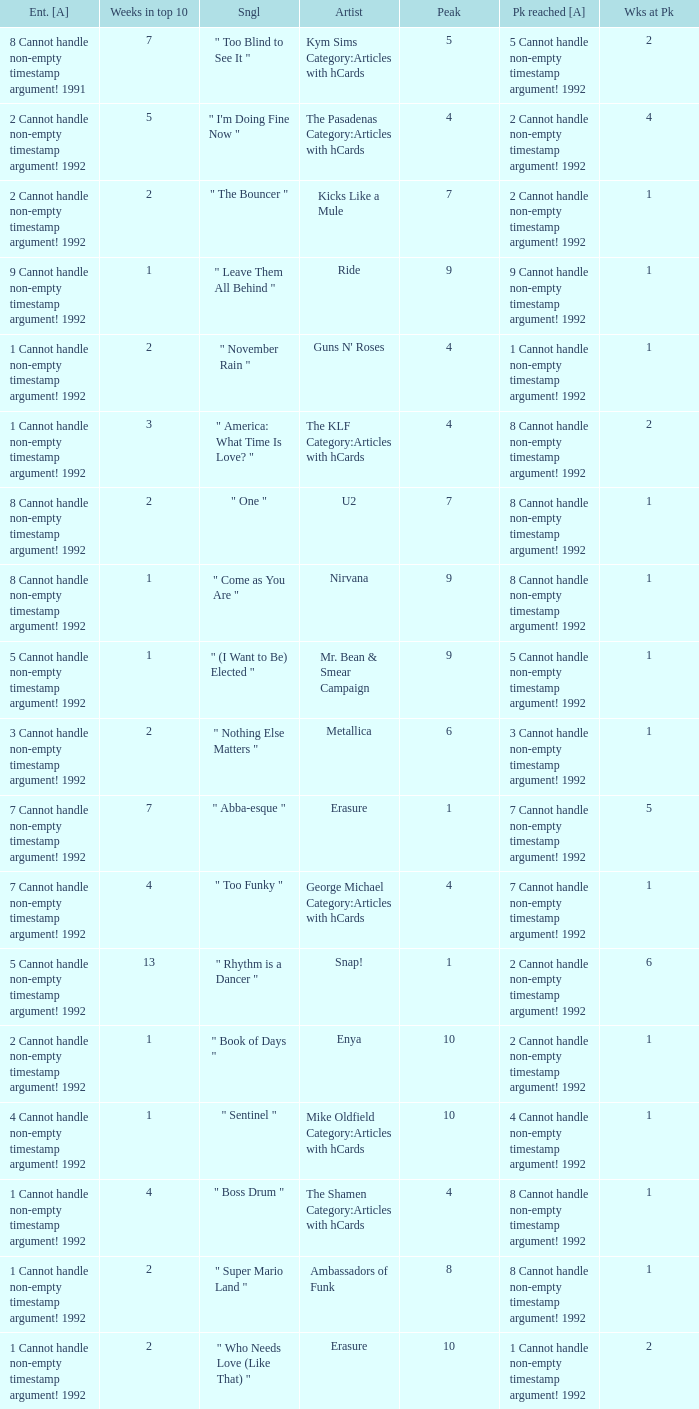If the summit achieved is 6 cannot deal with non-empty timestamp argument! 1992, what is the submitted? 6 Cannot handle non-empty timestamp argument! 1992. 